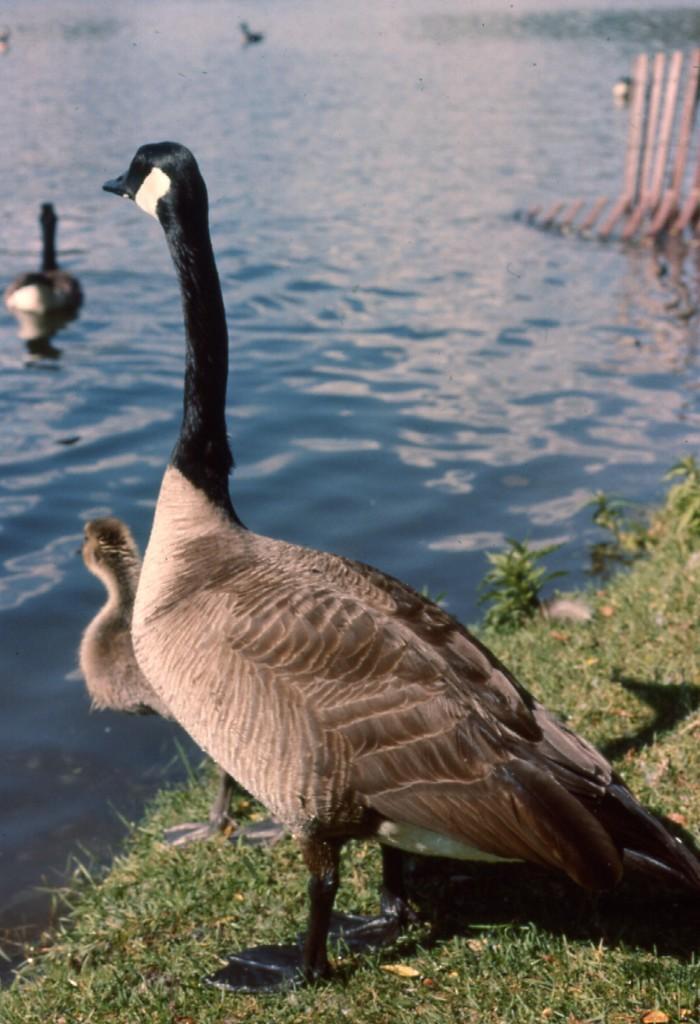How would you summarize this image in a sentence or two? In this image we can see some birds, some of them are on the water, one bird is on the ground, also we can see some plants, grass, and some wooden sticks. 